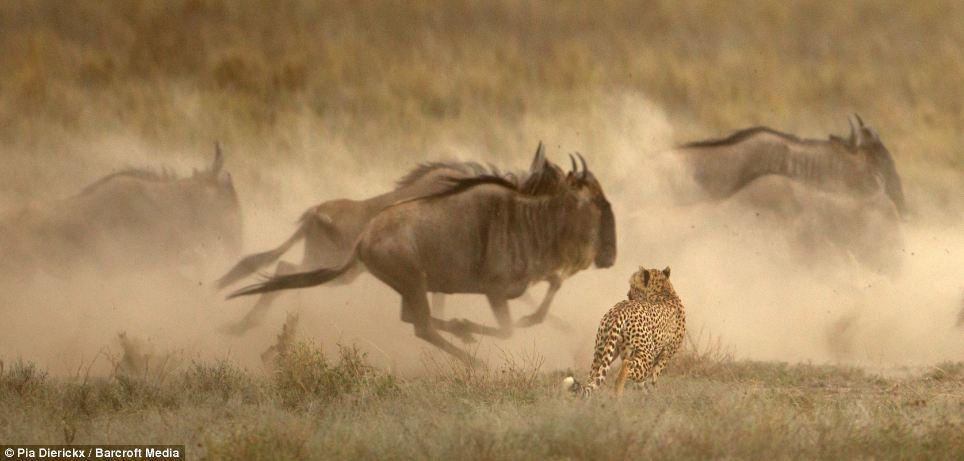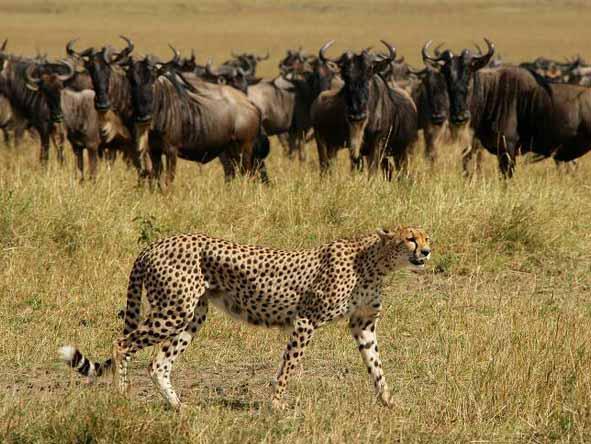The first image is the image on the left, the second image is the image on the right. For the images shown, is this caption "Both images show a cheetah chasing potential prey." true? Answer yes or no. No. The first image is the image on the left, the second image is the image on the right. Given the left and right images, does the statement "An image shows a back-turned cheetah running toward a herd of fleeing horned animals, which are kicking up clouds of dust." hold true? Answer yes or no. Yes. 